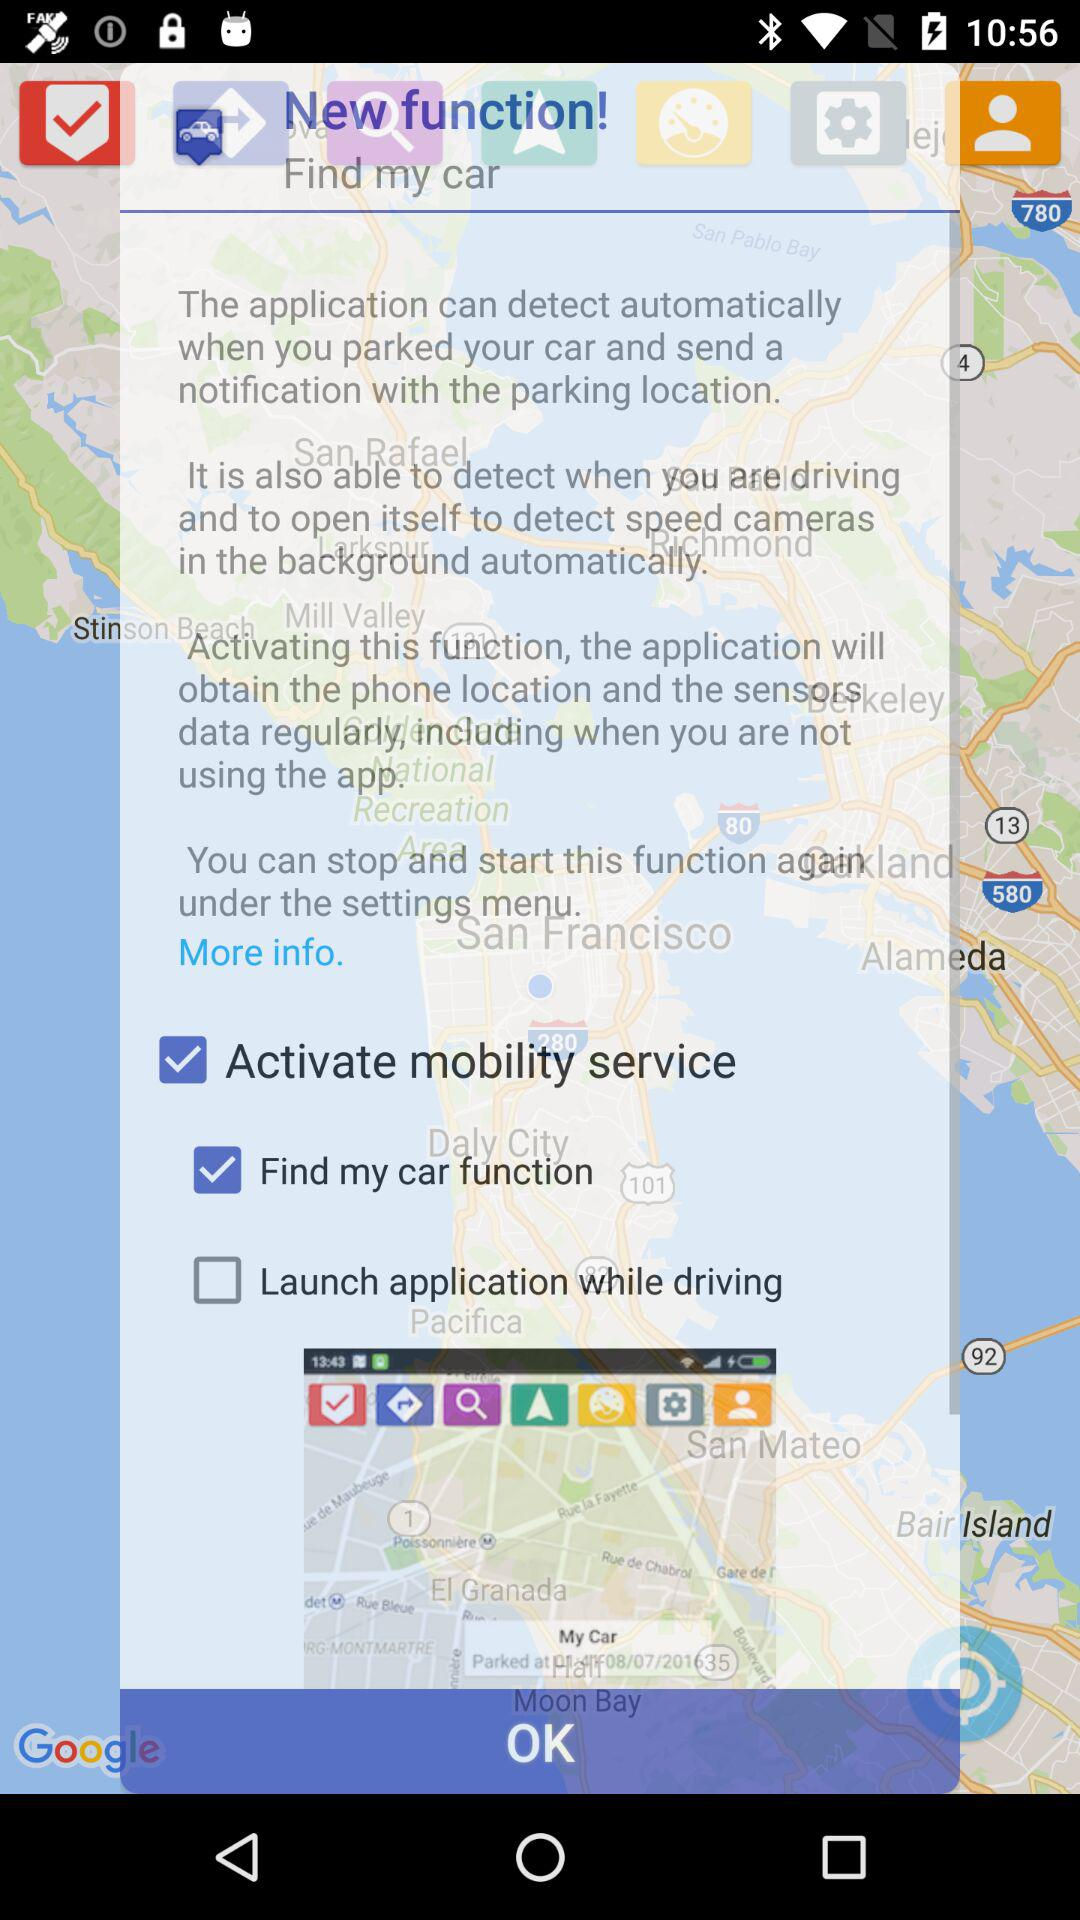How many check boxes are there on the screen?
Answer the question using a single word or phrase. 3 